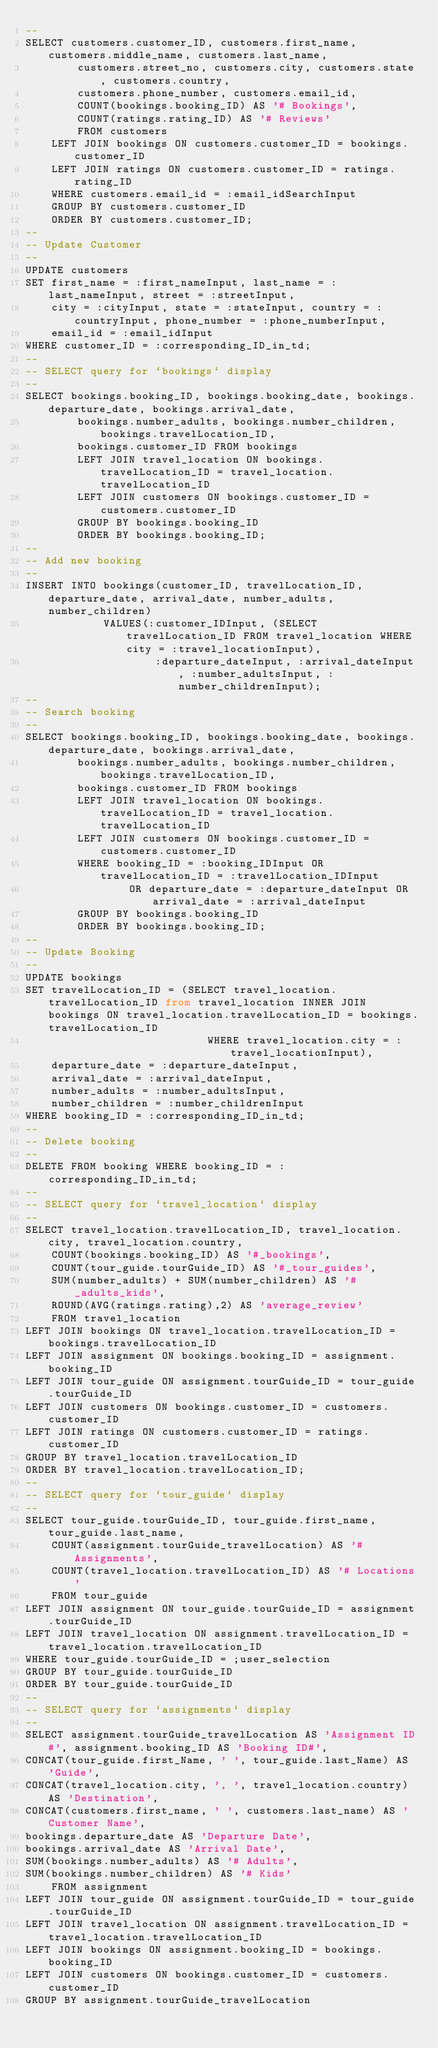<code> <loc_0><loc_0><loc_500><loc_500><_SQL_>--
SELECT customers.customer_ID, customers.first_name, customers.middle_name, customers.last_name, 
		customers.street_no, customers.city, customers.state, customers.country,
		customers.phone_number, customers.email_id, 
		COUNT(bookings.booking_ID) AS '# Bookings',
		COUNT(ratings.rating_ID) AS '# Reviews'
		FROM customers
	LEFT JOIN bookings ON customers.customer_ID = bookings.customer_ID
	LEFT JOIN ratings ON customers.customer_ID = ratings.rating_ID
	WHERE customers.email_id = :email_idSearchInput
	GROUP BY customers.customer_ID
	ORDER BY customers.customer_ID;
--
-- Update Customer
--
UPDATE customers
SET first_name = :first_nameInput, last_name = :last_nameInput, street = :streetInput,
	city = :cityInput, state = :stateInput, country = :countryInput, phone_number = :phone_numberInput,
	email_id = :email_idInput
WHERE customer_ID = :corresponding_ID_in_td;
--
-- SELECT query for `bookings` display
--
SELECT bookings.booking_ID, bookings.booking_date, bookings.departure_date, bookings.arrival_date,
		bookings.number_adults, bookings.number_children, bookings.travelLocation_ID,
		bookings.customer_ID FROM bookings
		LEFT JOIN travel_location ON bookings.travelLocation_ID = travel_location.travelLocation_ID
		LEFT JOIN customers ON bookings.customer_ID = customers.customer_ID
		GROUP BY bookings.booking_ID
		ORDER BY bookings.booking_ID;
--
-- Add new booking
--
INSERT INTO bookings(customer_ID, travelLocation_ID, departure_date, arrival_date, number_adults, number_children)
			VALUES(:customer_IDInput, (SELECT travelLocation_ID FROM travel_location WHERE city = :travel_locationInput),
				    :departure_dateInput, :arrival_dateInput, :number_adultsInput, :number_childrenInput);
--
-- Search booking
--
SELECT bookings.booking_ID, bookings.booking_date, bookings.departure_date, bookings.arrival_date,
		bookings.number_adults, bookings.number_children, bookings.travelLocation_ID,
		bookings.customer_ID FROM bookings
		LEFT JOIN travel_location ON bookings.travelLocation_ID = travel_location.travelLocation_ID
		LEFT JOIN customers ON bookings.customer_ID = customers.customer_ID
		WHERE booking_ID = :booking_IDInput OR travelLocation_ID = :travelLocation_IDInput 
				OR departure_date = :departure_dateInput OR arrival_date = :arrival_dateInput  
		GROUP BY bookings.booking_ID
		ORDER BY bookings.booking_ID;
--
-- Update Booking
--
UPDATE bookings
SET travelLocation_ID = (SELECT travel_location.travelLocation_ID from travel_location INNER JOIN bookings ON travel_location.travelLocation_ID = bookings.travelLocation_ID
							WHERE travel_location.city = :travel_locationInput),
	departure_date = :departure_dateInput,
	arrival_date = :arrival_dateInput,
	number_adults = :number_adultsInput,
	number_children = :number_childrenInput
WHERE booking_ID = :corresponding_ID_in_td;
--
-- Delete booking
--
DELETE FROM booking WHERE booking_ID = :corresponding_ID_in_td;
--
-- SELECT query for `travel_location` display
-- 
SELECT travel_location.travelLocation_ID, travel_location.city, travel_location.country, 
    COUNT(bookings.booking_ID) AS '#_bookings', 
    COUNT(tour_guide.tourGuide_ID) AS '#_tour_guides', 
    SUM(number_adults) + SUM(number_children) AS '#_adults_kids',
    ROUND(AVG(ratings.rating),2) AS 'average_review'
    FROM travel_location 
LEFT JOIN bookings ON travel_location.travelLocation_ID = bookings.travelLocation_ID
LEFT JOIN assignment ON bookings.booking_ID = assignment.booking_ID
LEFT JOIN tour_guide ON assignment.tourGuide_ID = tour_guide.tourGuide_ID
LEFT JOIN customers ON bookings.customer_ID = customers.customer_ID
LEFT JOIN ratings ON customers.customer_ID = ratings.customer_ID
GROUP BY travel_location.travelLocation_ID
ORDER BY travel_location.travelLocation_ID;
--
-- SELECT query for `tour_guide` display
-- 
SELECT tour_guide.tourGuide_ID, tour_guide.first_name, tour_guide.last_name, 
    COUNT(assignment.tourGuide_travelLocation) AS '# Assignments',
    COUNT(travel_location.travelLocation_ID) AS '# Locations'
    FROM tour_guide
LEFT JOIN assignment ON tour_guide.tourGuide_ID = assignment.tourGuide_ID
LEFT JOIN travel_location ON assignment.travelLocation_ID = travel_location.travelLocation_ID
WHERE tour_guide.tourGuide_ID = ;user_selection
GROUP BY tour_guide.tourGuide_ID
ORDER BY tour_guide.tourGuide_ID
--
-- SELECT query for `assignments` display
-- 
SELECT assignment.tourGuide_travelLocation AS 'Assignment ID#', assignment.booking_ID AS 'Booking ID#',
CONCAT(tour_guide.first_Name, ' ', tour_guide.last_Name) AS 'Guide',
CONCAT(travel_location.city, ', ', travel_location.country) AS 'Destination',
CONCAT(customers.first_name, ' ', customers.last_name) AS 'Customer Name',
bookings.departure_date AS 'Departure Date',
bookings.arrival_date AS 'Arrival Date',
SUM(bookings.number_adults) AS '# Adults',
SUM(bookings.number_children) AS '# Kids'
    FROM assignment
LEFT JOIN tour_guide ON assignment.tourGuide_ID = tour_guide.tourGuide_ID
LEFT JOIN travel_location ON assignment.travelLocation_ID = travel_location.travelLocation_ID
LEFT JOIN bookings ON assignment.booking_ID = bookings.booking_ID
LEFT JOIN customers ON bookings.customer_ID = customers.customer_ID
GROUP BY assignment.tourGuide_travelLocation</code> 